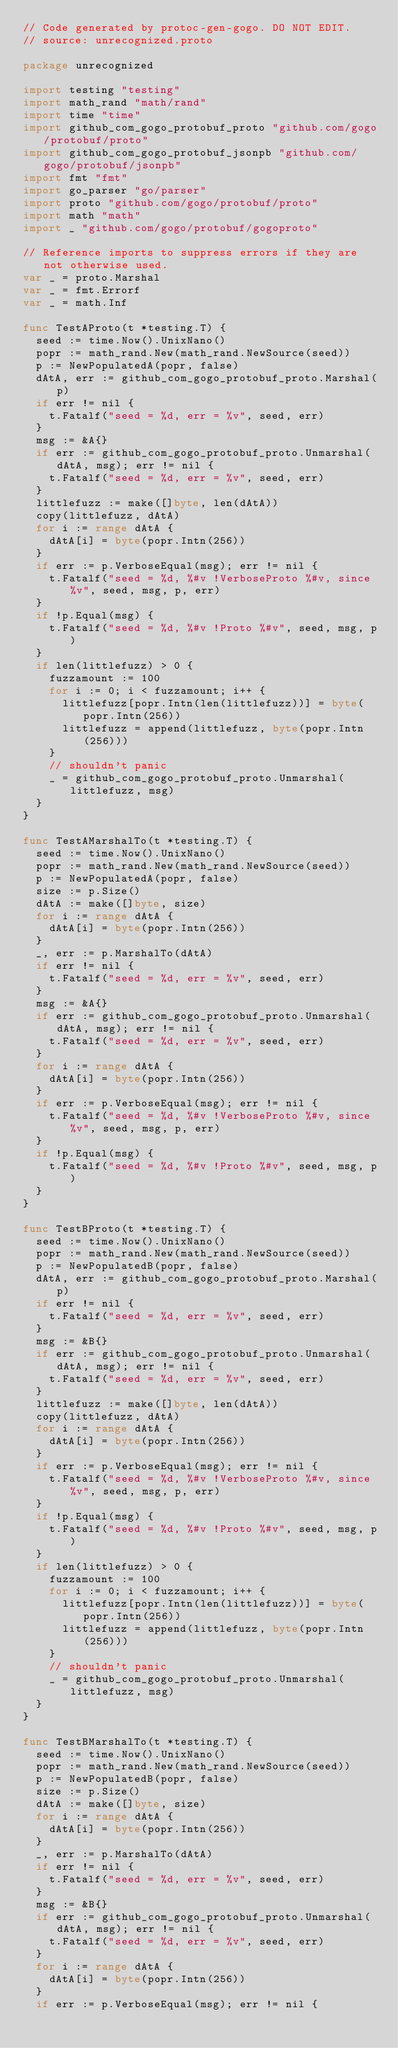Convert code to text. <code><loc_0><loc_0><loc_500><loc_500><_Go_>// Code generated by protoc-gen-gogo. DO NOT EDIT.
// source: unrecognized.proto

package unrecognized

import testing "testing"
import math_rand "math/rand"
import time "time"
import github_com_gogo_protobuf_proto "github.com/gogo/protobuf/proto"
import github_com_gogo_protobuf_jsonpb "github.com/gogo/protobuf/jsonpb"
import fmt "fmt"
import go_parser "go/parser"
import proto "github.com/gogo/protobuf/proto"
import math "math"
import _ "github.com/gogo/protobuf/gogoproto"

// Reference imports to suppress errors if they are not otherwise used.
var _ = proto.Marshal
var _ = fmt.Errorf
var _ = math.Inf

func TestAProto(t *testing.T) {
	seed := time.Now().UnixNano()
	popr := math_rand.New(math_rand.NewSource(seed))
	p := NewPopulatedA(popr, false)
	dAtA, err := github_com_gogo_protobuf_proto.Marshal(p)
	if err != nil {
		t.Fatalf("seed = %d, err = %v", seed, err)
	}
	msg := &A{}
	if err := github_com_gogo_protobuf_proto.Unmarshal(dAtA, msg); err != nil {
		t.Fatalf("seed = %d, err = %v", seed, err)
	}
	littlefuzz := make([]byte, len(dAtA))
	copy(littlefuzz, dAtA)
	for i := range dAtA {
		dAtA[i] = byte(popr.Intn(256))
	}
	if err := p.VerboseEqual(msg); err != nil {
		t.Fatalf("seed = %d, %#v !VerboseProto %#v, since %v", seed, msg, p, err)
	}
	if !p.Equal(msg) {
		t.Fatalf("seed = %d, %#v !Proto %#v", seed, msg, p)
	}
	if len(littlefuzz) > 0 {
		fuzzamount := 100
		for i := 0; i < fuzzamount; i++ {
			littlefuzz[popr.Intn(len(littlefuzz))] = byte(popr.Intn(256))
			littlefuzz = append(littlefuzz, byte(popr.Intn(256)))
		}
		// shouldn't panic
		_ = github_com_gogo_protobuf_proto.Unmarshal(littlefuzz, msg)
	}
}

func TestAMarshalTo(t *testing.T) {
	seed := time.Now().UnixNano()
	popr := math_rand.New(math_rand.NewSource(seed))
	p := NewPopulatedA(popr, false)
	size := p.Size()
	dAtA := make([]byte, size)
	for i := range dAtA {
		dAtA[i] = byte(popr.Intn(256))
	}
	_, err := p.MarshalTo(dAtA)
	if err != nil {
		t.Fatalf("seed = %d, err = %v", seed, err)
	}
	msg := &A{}
	if err := github_com_gogo_protobuf_proto.Unmarshal(dAtA, msg); err != nil {
		t.Fatalf("seed = %d, err = %v", seed, err)
	}
	for i := range dAtA {
		dAtA[i] = byte(popr.Intn(256))
	}
	if err := p.VerboseEqual(msg); err != nil {
		t.Fatalf("seed = %d, %#v !VerboseProto %#v, since %v", seed, msg, p, err)
	}
	if !p.Equal(msg) {
		t.Fatalf("seed = %d, %#v !Proto %#v", seed, msg, p)
	}
}

func TestBProto(t *testing.T) {
	seed := time.Now().UnixNano()
	popr := math_rand.New(math_rand.NewSource(seed))
	p := NewPopulatedB(popr, false)
	dAtA, err := github_com_gogo_protobuf_proto.Marshal(p)
	if err != nil {
		t.Fatalf("seed = %d, err = %v", seed, err)
	}
	msg := &B{}
	if err := github_com_gogo_protobuf_proto.Unmarshal(dAtA, msg); err != nil {
		t.Fatalf("seed = %d, err = %v", seed, err)
	}
	littlefuzz := make([]byte, len(dAtA))
	copy(littlefuzz, dAtA)
	for i := range dAtA {
		dAtA[i] = byte(popr.Intn(256))
	}
	if err := p.VerboseEqual(msg); err != nil {
		t.Fatalf("seed = %d, %#v !VerboseProto %#v, since %v", seed, msg, p, err)
	}
	if !p.Equal(msg) {
		t.Fatalf("seed = %d, %#v !Proto %#v", seed, msg, p)
	}
	if len(littlefuzz) > 0 {
		fuzzamount := 100
		for i := 0; i < fuzzamount; i++ {
			littlefuzz[popr.Intn(len(littlefuzz))] = byte(popr.Intn(256))
			littlefuzz = append(littlefuzz, byte(popr.Intn(256)))
		}
		// shouldn't panic
		_ = github_com_gogo_protobuf_proto.Unmarshal(littlefuzz, msg)
	}
}

func TestBMarshalTo(t *testing.T) {
	seed := time.Now().UnixNano()
	popr := math_rand.New(math_rand.NewSource(seed))
	p := NewPopulatedB(popr, false)
	size := p.Size()
	dAtA := make([]byte, size)
	for i := range dAtA {
		dAtA[i] = byte(popr.Intn(256))
	}
	_, err := p.MarshalTo(dAtA)
	if err != nil {
		t.Fatalf("seed = %d, err = %v", seed, err)
	}
	msg := &B{}
	if err := github_com_gogo_protobuf_proto.Unmarshal(dAtA, msg); err != nil {
		t.Fatalf("seed = %d, err = %v", seed, err)
	}
	for i := range dAtA {
		dAtA[i] = byte(popr.Intn(256))
	}
	if err := p.VerboseEqual(msg); err != nil {</code> 